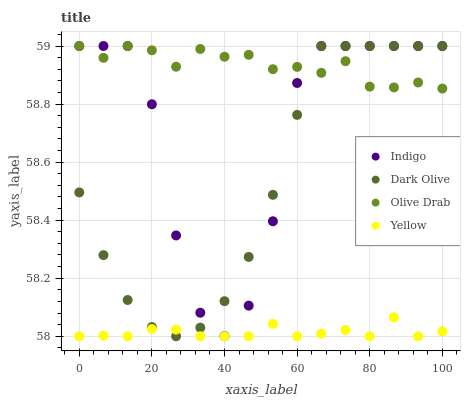Does Yellow have the minimum area under the curve?
Answer yes or no. Yes. Does Olive Drab have the maximum area under the curve?
Answer yes or no. Yes. Does Indigo have the minimum area under the curve?
Answer yes or no. No. Does Indigo have the maximum area under the curve?
Answer yes or no. No. Is Yellow the smoothest?
Answer yes or no. Yes. Is Indigo the roughest?
Answer yes or no. Yes. Is Indigo the smoothest?
Answer yes or no. No. Is Yellow the roughest?
Answer yes or no. No. Does Yellow have the lowest value?
Answer yes or no. Yes. Does Indigo have the lowest value?
Answer yes or no. No. Does Olive Drab have the highest value?
Answer yes or no. Yes. Does Yellow have the highest value?
Answer yes or no. No. Is Yellow less than Indigo?
Answer yes or no. Yes. Is Olive Drab greater than Yellow?
Answer yes or no. Yes. Does Dark Olive intersect Olive Drab?
Answer yes or no. Yes. Is Dark Olive less than Olive Drab?
Answer yes or no. No. Is Dark Olive greater than Olive Drab?
Answer yes or no. No. Does Yellow intersect Indigo?
Answer yes or no. No. 